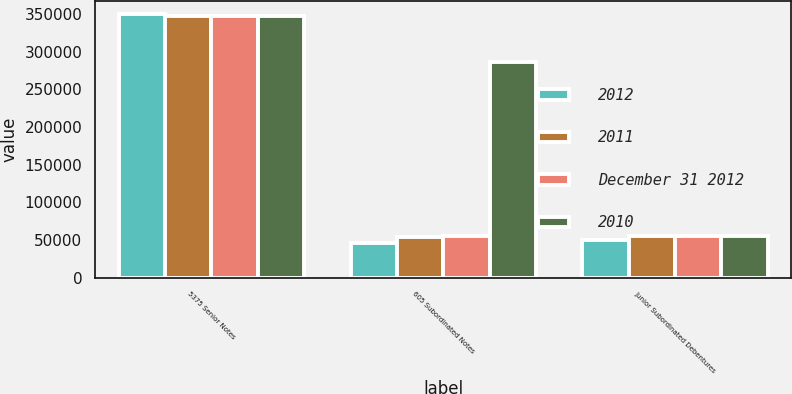<chart> <loc_0><loc_0><loc_500><loc_500><stacked_bar_chart><ecel><fcel>5375 Senior Notes<fcel>605 Subordinated Notes<fcel>Junior Subordinated Debentures<nl><fcel>2012<fcel>350000<fcel>45964<fcel>50000<nl><fcel>2011<fcel>347995<fcel>54571<fcel>55196<nl><fcel>December 31 2012<fcel>347793<fcel>55075<fcel>55372<nl><fcel>2010<fcel>347601<fcel>285937<fcel>55548<nl></chart> 